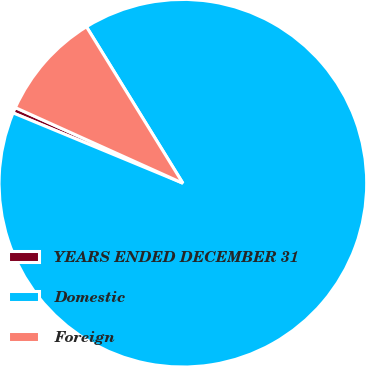Convert chart. <chart><loc_0><loc_0><loc_500><loc_500><pie_chart><fcel>YEARS ENDED DECEMBER 31<fcel>Domestic<fcel>Foreign<nl><fcel>0.5%<fcel>90.04%<fcel>9.46%<nl></chart> 